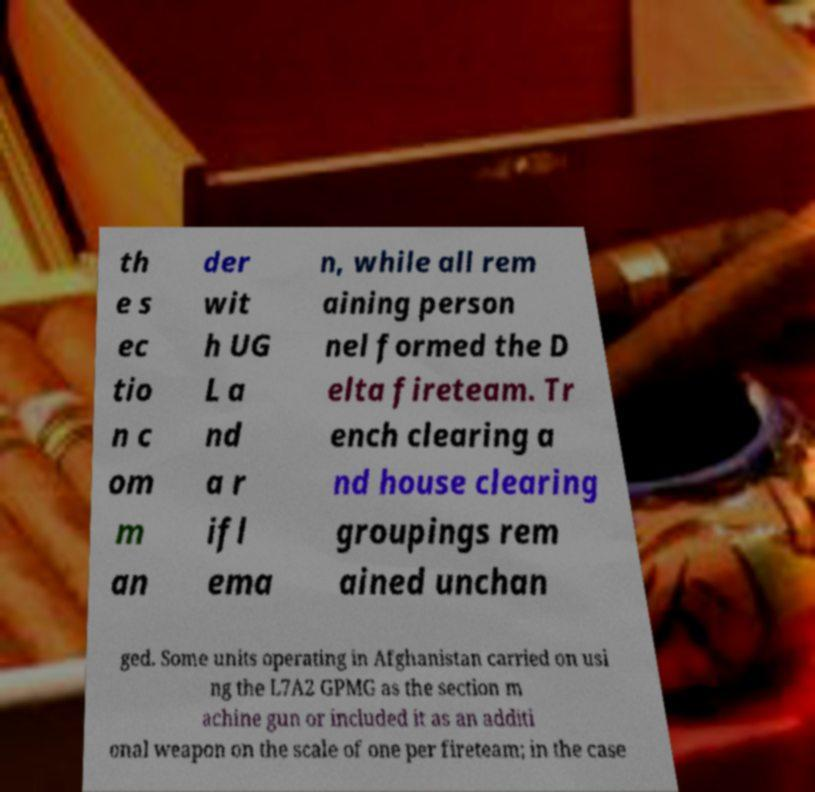For documentation purposes, I need the text within this image transcribed. Could you provide that? th e s ec tio n c om m an der wit h UG L a nd a r ifl ema n, while all rem aining person nel formed the D elta fireteam. Tr ench clearing a nd house clearing groupings rem ained unchan ged. Some units operating in Afghanistan carried on usi ng the L7A2 GPMG as the section m achine gun or included it as an additi onal weapon on the scale of one per fireteam; in the case 